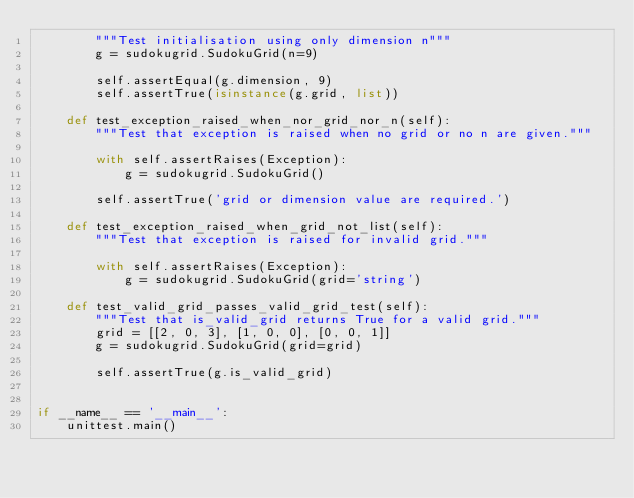<code> <loc_0><loc_0><loc_500><loc_500><_Python_>        """Test initialisation using only dimension n"""
        g = sudokugrid.SudokuGrid(n=9)

        self.assertEqual(g.dimension, 9)
        self.assertTrue(isinstance(g.grid, list))

    def test_exception_raised_when_nor_grid_nor_n(self):
        """Test that exception is raised when no grid or no n are given."""

        with self.assertRaises(Exception):
            g = sudokugrid.SudokuGrid()

        self.assertTrue('grid or dimension value are required.')

    def test_exception_raised_when_grid_not_list(self):
        """Test that exception is raised for invalid grid."""

        with self.assertRaises(Exception):
            g = sudokugrid.SudokuGrid(grid='string')

    def test_valid_grid_passes_valid_grid_test(self):
        """Test that is_valid_grid returns True for a valid grid."""
        grid = [[2, 0, 3], [1, 0, 0], [0, 0, 1]]
        g = sudokugrid.SudokuGrid(grid=grid)

        self.assertTrue(g.is_valid_grid)


if __name__ == '__main__':
    unittest.main()
</code> 